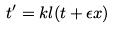<formula> <loc_0><loc_0><loc_500><loc_500>t ^ { \prime } = k l ( t + \epsilon x )</formula> 